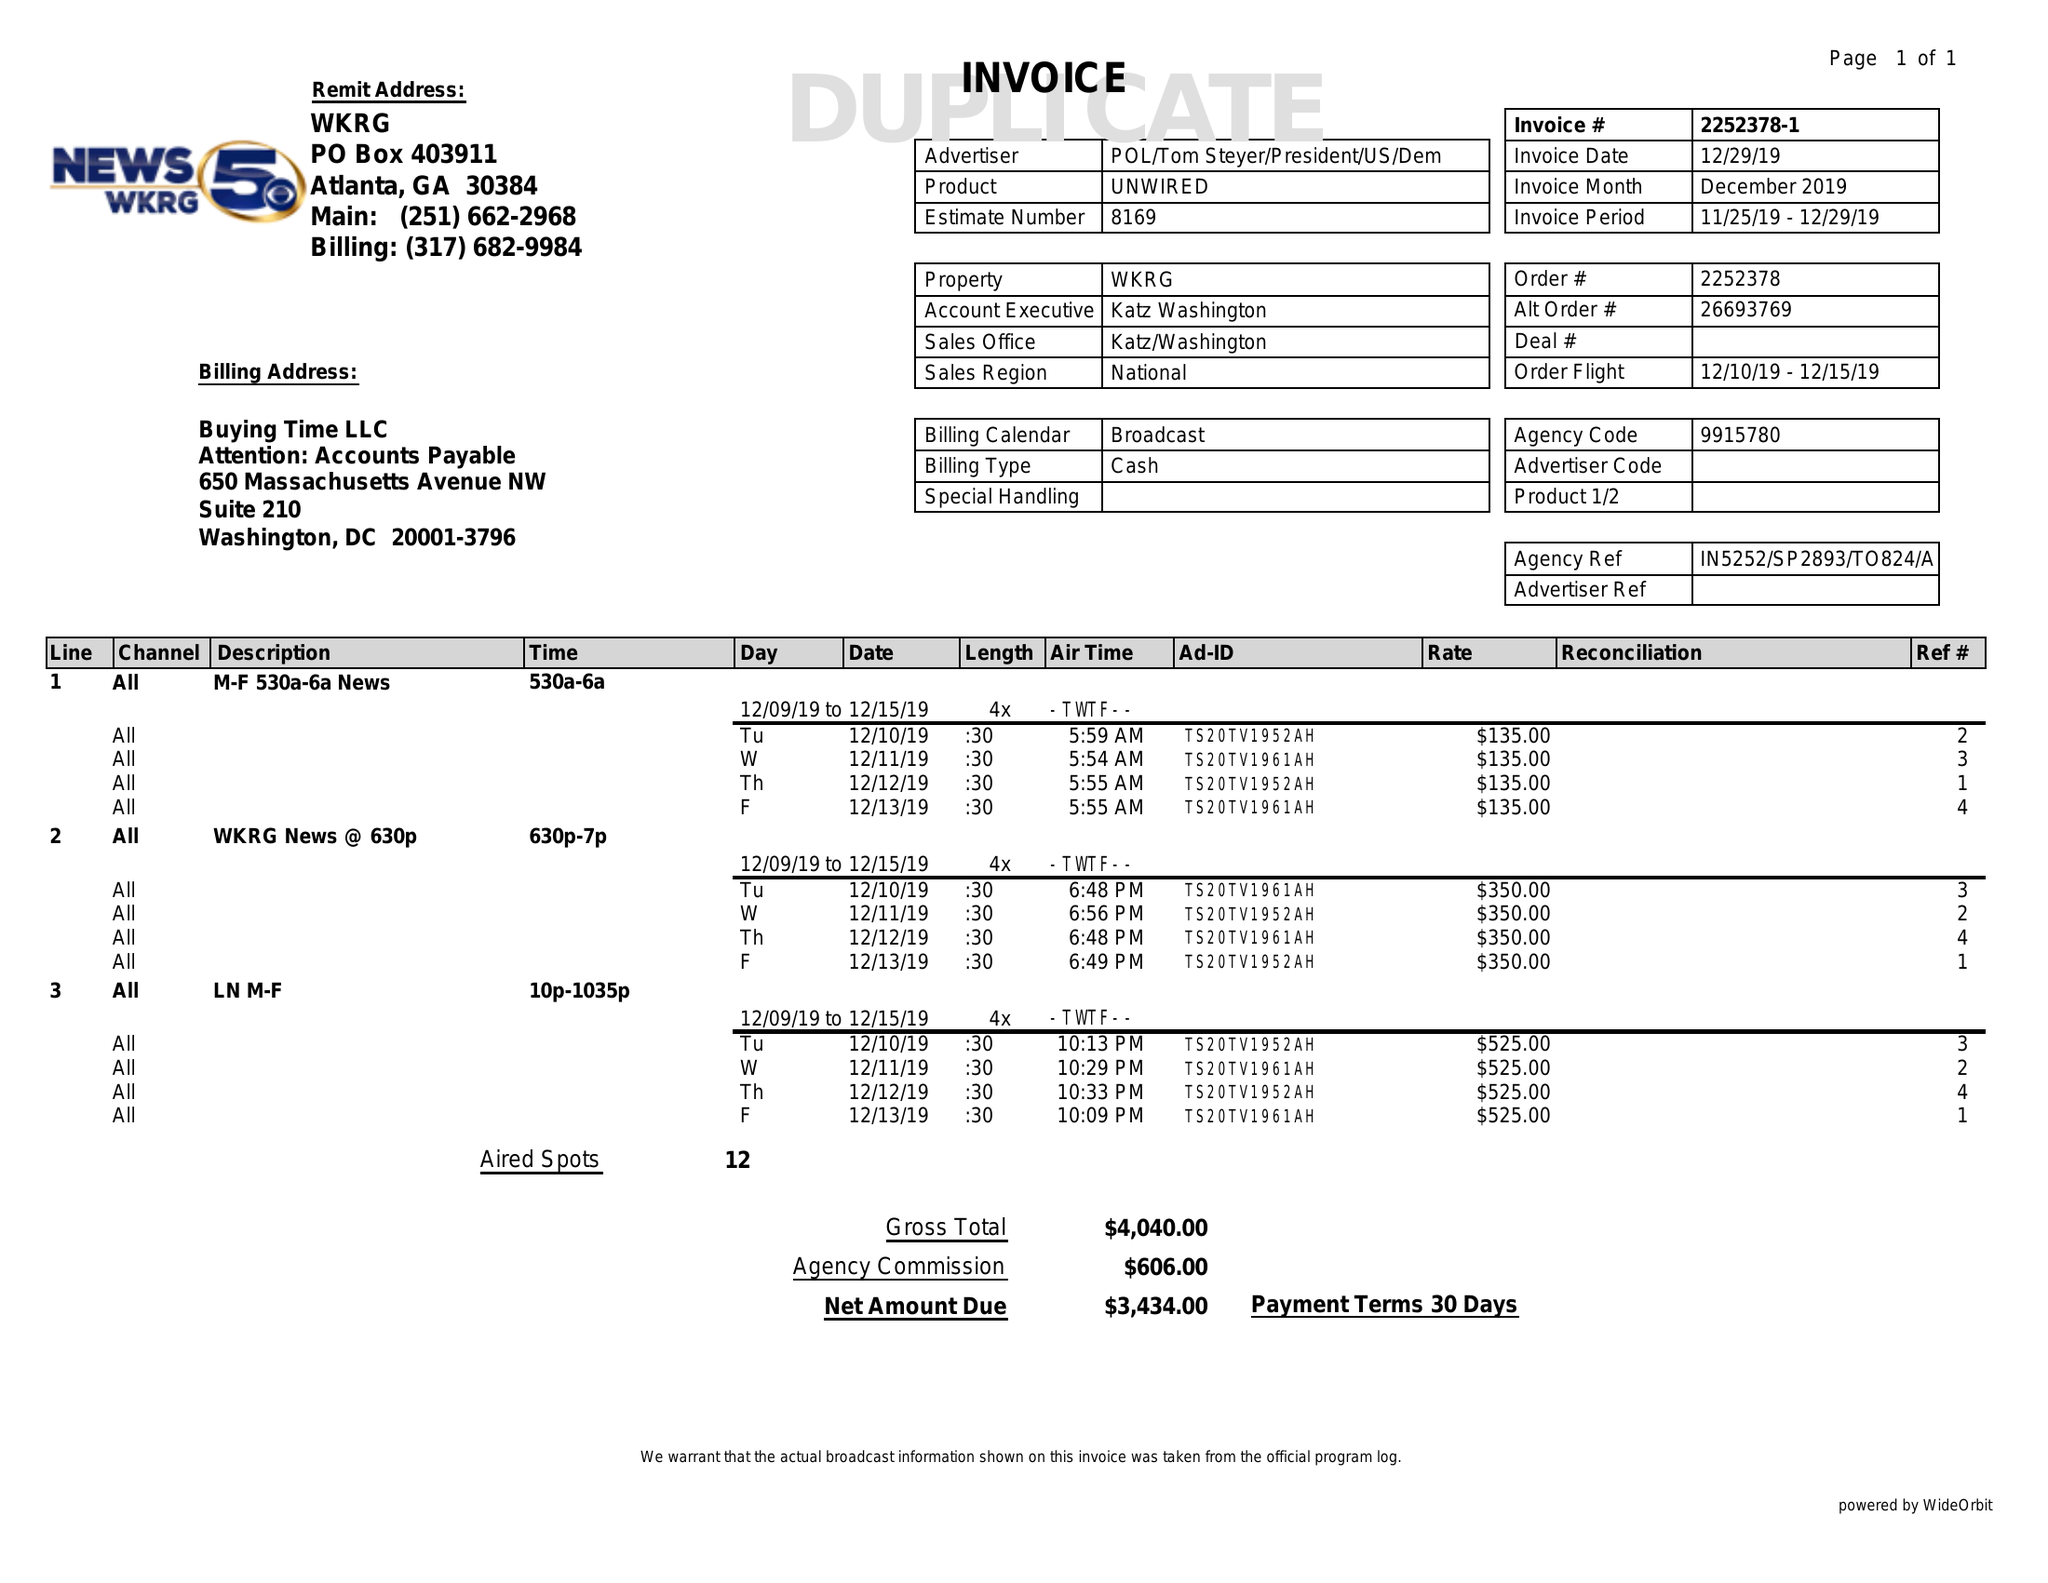What is the value for the flight_to?
Answer the question using a single word or phrase. 12/15/19 